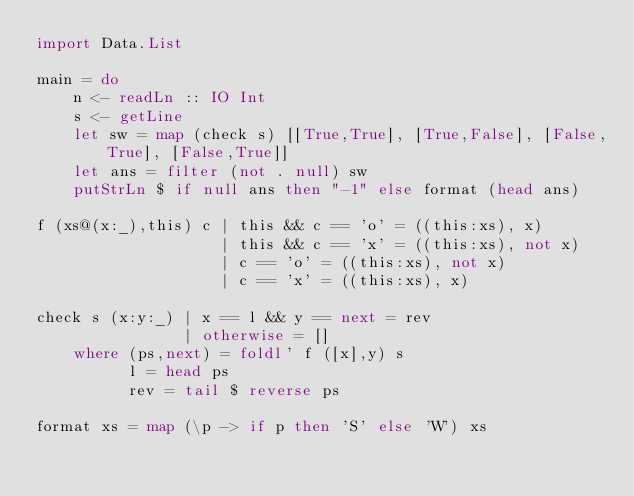<code> <loc_0><loc_0><loc_500><loc_500><_Haskell_>import Data.List

main = do
    n <- readLn :: IO Int
    s <- getLine
    let sw = map (check s) [[True,True], [True,False], [False,True], [False,True]]
    let ans = filter (not . null) sw
    putStrLn $ if null ans then "-1" else format (head ans)

f (xs@(x:_),this) c | this && c == 'o' = ((this:xs), x)
                    | this && c == 'x' = ((this:xs), not x)
                    | c == 'o' = ((this:xs), not x)
                    | c == 'x' = ((this:xs), x)

check s (x:y:_) | x == l && y == next = rev
                | otherwise = []
    where (ps,next) = foldl' f ([x],y) s
          l = head ps
          rev = tail $ reverse ps

format xs = map (\p -> if p then 'S' else 'W') xs</code> 